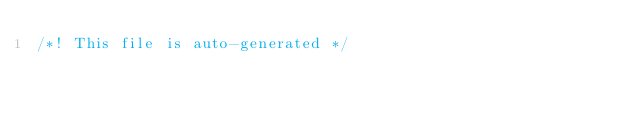<code> <loc_0><loc_0><loc_500><loc_500><_CSS_>/*! This file is auto-generated */</code> 